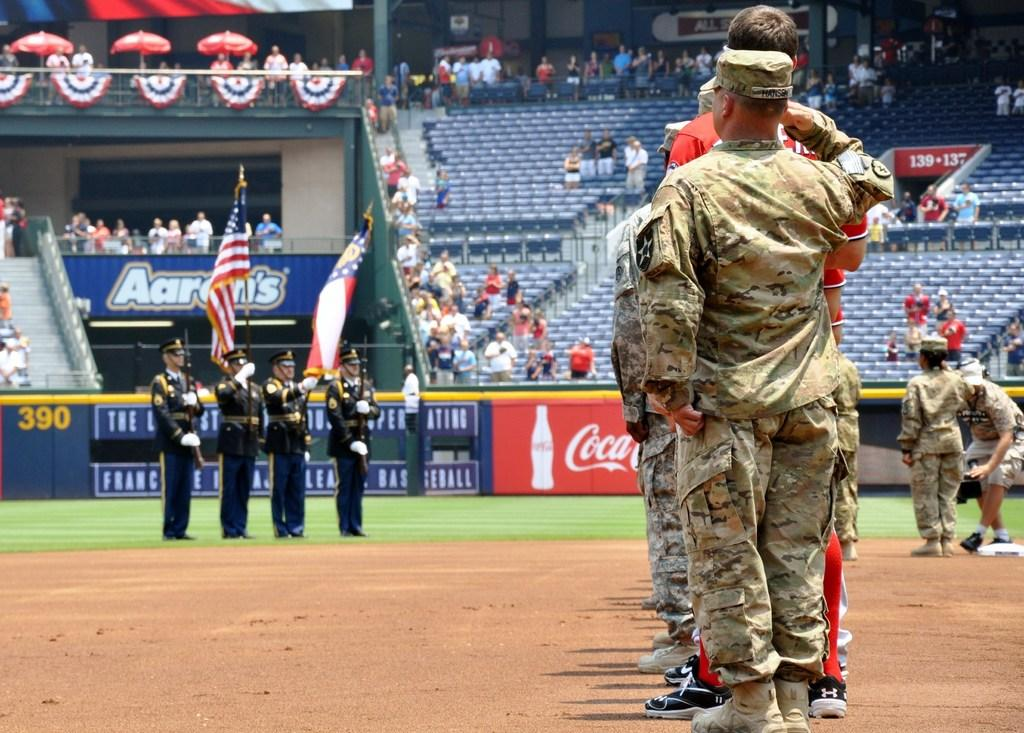<image>
Offer a succinct explanation of the picture presented. Troops are onfield at a baseball game by a Coca Cola sign on the fence. 